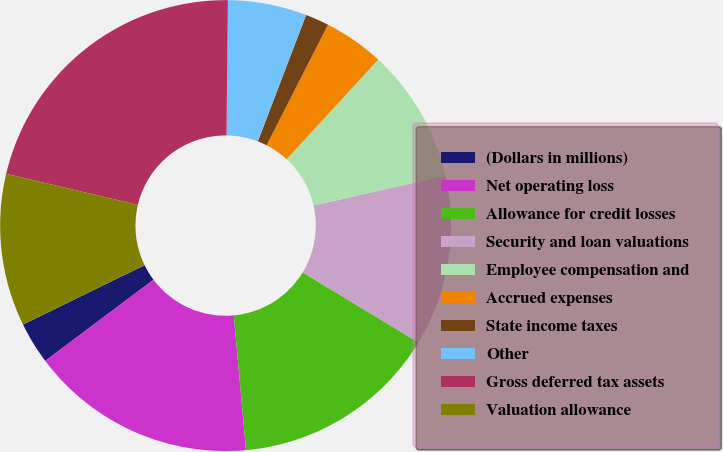Convert chart to OTSL. <chart><loc_0><loc_0><loc_500><loc_500><pie_chart><fcel>(Dollars in millions)<fcel>Net operating loss<fcel>Allowance for credit losses<fcel>Security and loan valuations<fcel>Employee compensation and<fcel>Accrued expenses<fcel>State income taxes<fcel>Other<fcel>Gross deferred tax assets<fcel>Valuation allowance<nl><fcel>3.01%<fcel>16.2%<fcel>14.88%<fcel>12.24%<fcel>9.6%<fcel>4.33%<fcel>1.69%<fcel>5.65%<fcel>21.47%<fcel>10.92%<nl></chart> 